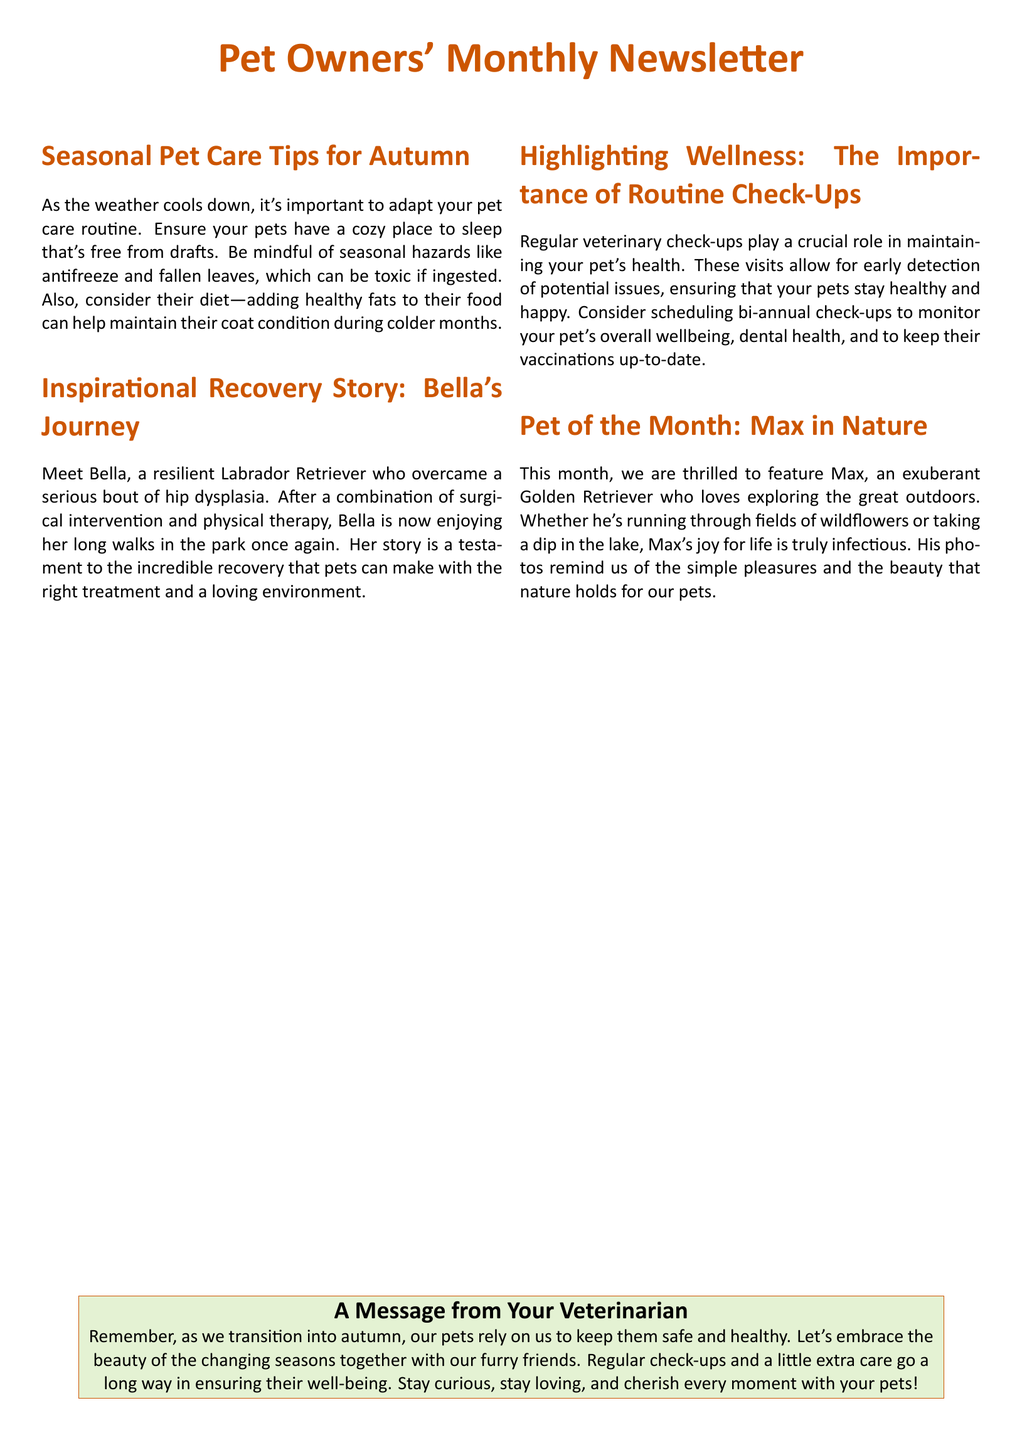What is the title of the newsletter? The title of the newsletter is prominently displayed at the beginning of the document.
Answer: Pet Owners' Monthly Newsletter What is Bella's condition? Bella's condition refers to the health issue she faced before her recovery, specified in the inspirational story.
Answer: Hip dysplasia What pet is featured in "Pet of the Month"? This question focuses on identifying the specific pet highlighted in that section of the document.
Answer: Max What type of tips are provided for autumn? The section title indicates that these tips are specifically related to caring for pets in the autumn season.
Answer: Seasonal Pet Care Tips How often should pet check-ups be scheduled? The document suggests a frequency for regular veterinary check-ups in the wellness section.
Answer: Bi-annual What does Bella enjoy doing now? This question pertains to the activities that Bella can now participate in after her recovery.
Answer: Long walks in the park Which color is used for the newsletter's header? This question relates to the design elements present in the document, specifically the color.
Answer: Autumn What is the main message from the veterinarian? The main message is about keeping pets safe and healthy through proper care.
Answer: Regular check-ups and a little extra care go a long way in ensuring their well-being 